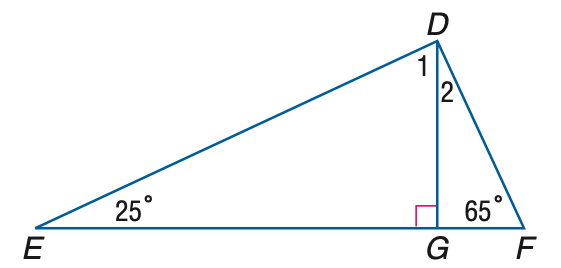Question: Find the measure of \angle 2.
Choices:
A. 25
B. 35
C. 45
D. 55
Answer with the letter. Answer: A 